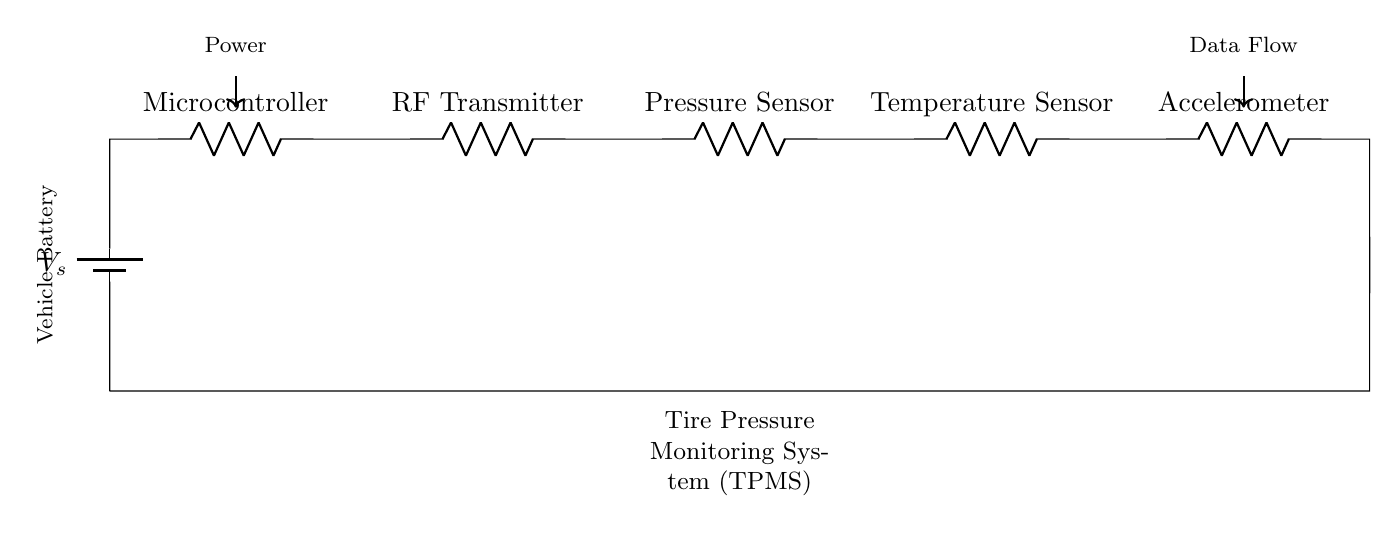What is the source voltage in this circuit? The source voltage is indicated by the battery symbol labeled as V_s, representing the potential difference provided to the circuit.
Answer: V_s What components are present in this TPMS circuit? The components listed from left to right include a Microcontroller, RF Transmitter, Pressure Sensor, Temperature Sensor, and Accelerometer, as labeled in the diagram.
Answer: Microcontroller, RF Transmitter, Pressure Sensor, Temperature Sensor, Accelerometer How many resistors are in the circuit? Each component in the diagram is represented as a resistor, and there are five labeled components, thus there are five resistors.
Answer: 5 What direction does the data flow in the circuit? The data flow is indicated by an arrow pointing toward the right, implying that data travels from the last component towards the data processing destination.
Answer: Right Which component is directly connected to the vehicle battery? The Microcontroller is directly connected to the vehicle battery, as it is the first component following the battery in the circuit.
Answer: Microcontroller What will happen if one component fails in the series circuit? In a series circuit, if one component fails (like a broken resistor), the entire circuit will be interrupted, and no current will flow through other components.
Answer: Circuit fails 